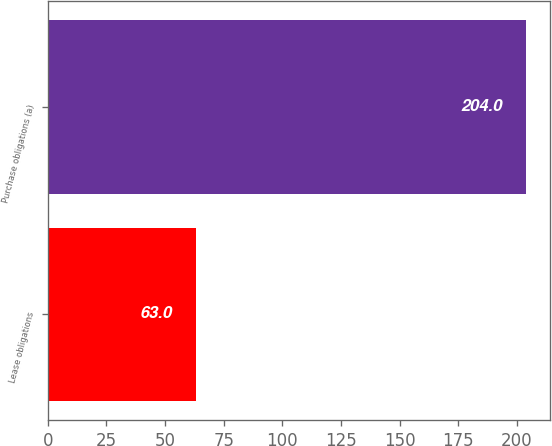Convert chart to OTSL. <chart><loc_0><loc_0><loc_500><loc_500><bar_chart><fcel>Lease obligations<fcel>Purchase obligations (a)<nl><fcel>63<fcel>204<nl></chart> 